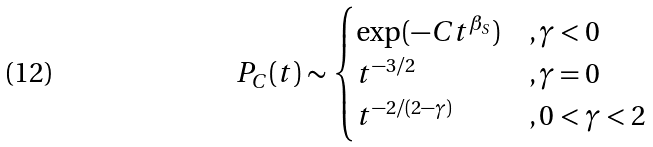<formula> <loc_0><loc_0><loc_500><loc_500>P _ { C } ( t ) \sim \begin{cases} \exp ( - C t ^ { \beta _ { S } } ) & , \gamma < 0 \\ t ^ { - 3 / 2 } & , \gamma = 0 \\ t ^ { - 2 / ( 2 - \gamma ) } & , 0 < \gamma < 2 \end{cases}</formula> 